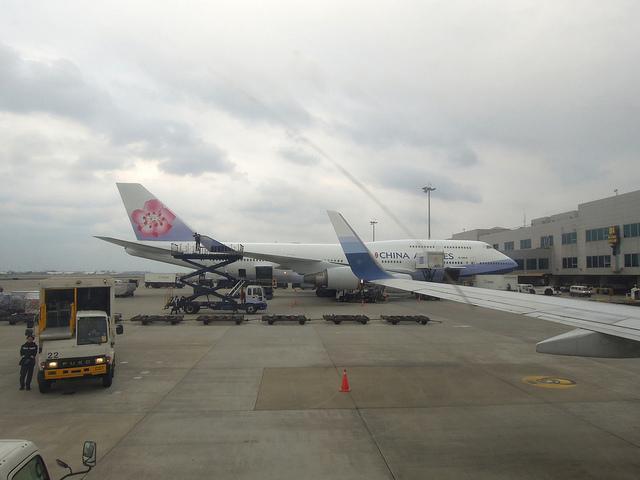How many planes are there?
Give a very brief answer. 2. How many planes do you see?
Give a very brief answer. 2. How many red cones are in the picture?
Give a very brief answer. 1. How many trucks are visible?
Give a very brief answer. 2. How many airplanes are in the photo?
Give a very brief answer. 2. How many beds are there?
Give a very brief answer. 0. 